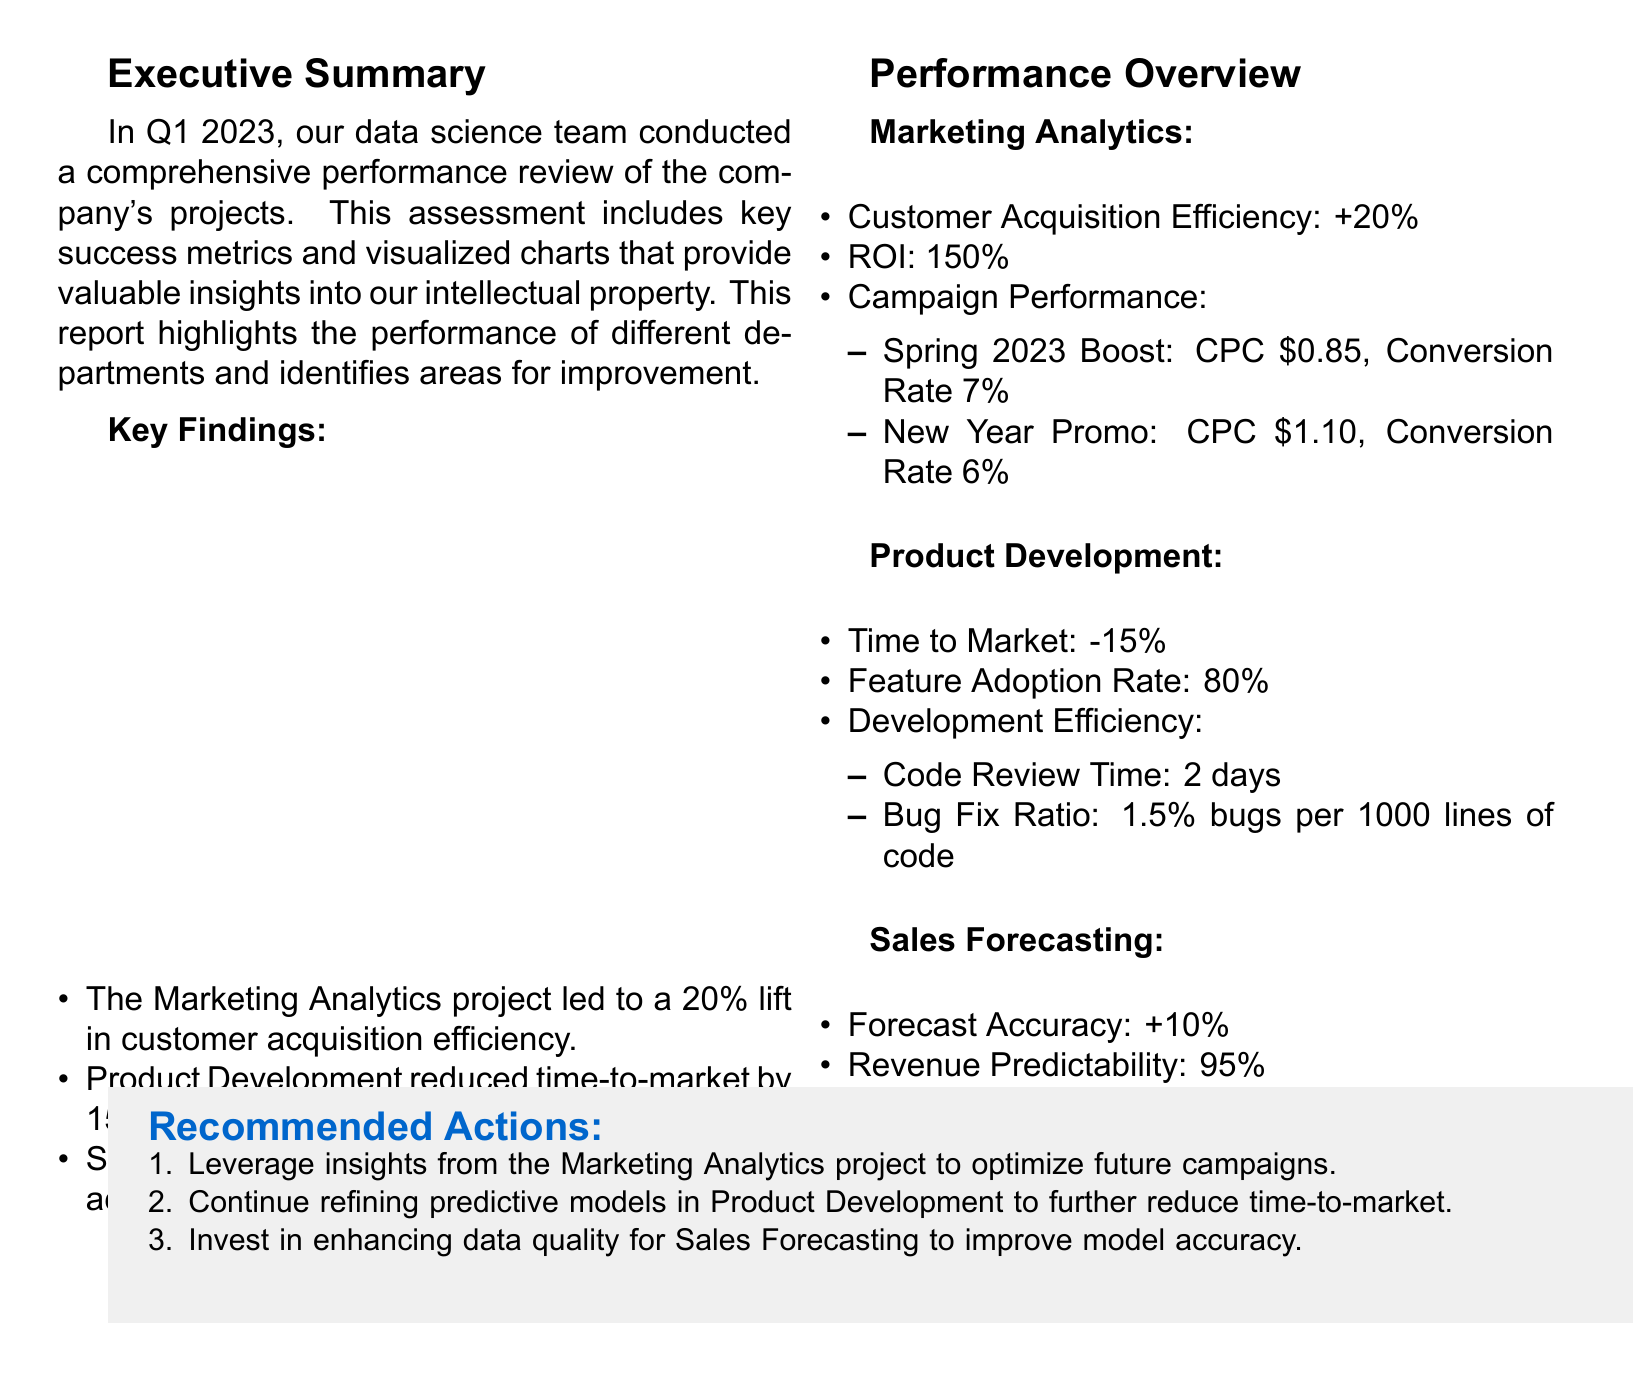What was the customer acquisition efficiency increase for Marketing Analytics? The document states that there was a 20% lift in customer acquisition efficiency for the Marketing Analytics project.
Answer: 20% What is the ROI for the Marketing Analytics project? According to the document, the return on investment (ROI) for the Marketing Analytics project is 150%.
Answer: 150% By what percentage did Product Development reduce time-to-market? The document mentions that Product Development reduced time-to-market by 15%.
Answer: 15% What was the forecast accuracy increase reported in Sales Forecasting? The document indicates that Sales Forecasting achieved a 10% increase in forecast accuracy.
Answer: 10% What is the feature adoption rate for Product Development? The document specifies that the feature adoption rate is 80%.
Answer: 80% What recommended action relates to Marketing Analytics? The recommended action is to leverage insights from the Marketing Analytics project to optimize future campaigns.
Answer: Optimize future campaigns How many days did the Code Review take in Product Development? The document states that the Code Review time was 2 days.
Answer: 2 days Which predictive model had the better Mean Absolute Percentage Error in Sales Forecasting? The document shows that the Prophet model had a MAPE of 4.5%, better than ARIMA's 5.2%.
Answer: Prophet What is the conversion rate for the New Year Promo campaign? The document indicates that the conversion rate for the New Year Promo campaign was 6%.
Answer: 6% 